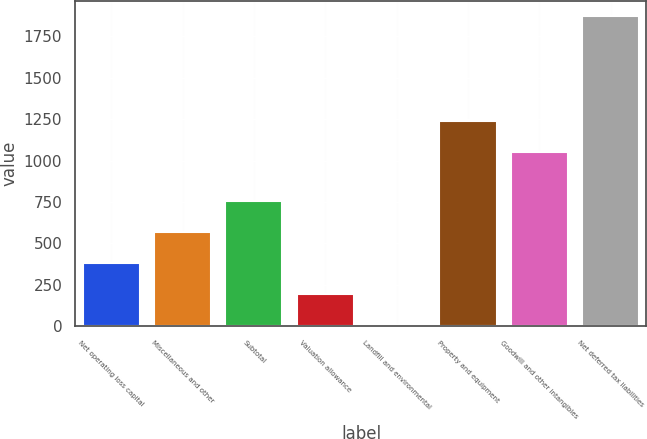<chart> <loc_0><loc_0><loc_500><loc_500><bar_chart><fcel>Net operating loss capital<fcel>Miscellaneous and other<fcel>Subtotal<fcel>Valuation allowance<fcel>Landfill and environmental<fcel>Property and equipment<fcel>Goodwill and other intangibles<fcel>Net deferred tax liabilities<nl><fcel>383<fcel>569<fcel>755<fcel>197<fcel>11<fcel>1236<fcel>1050<fcel>1871<nl></chart> 